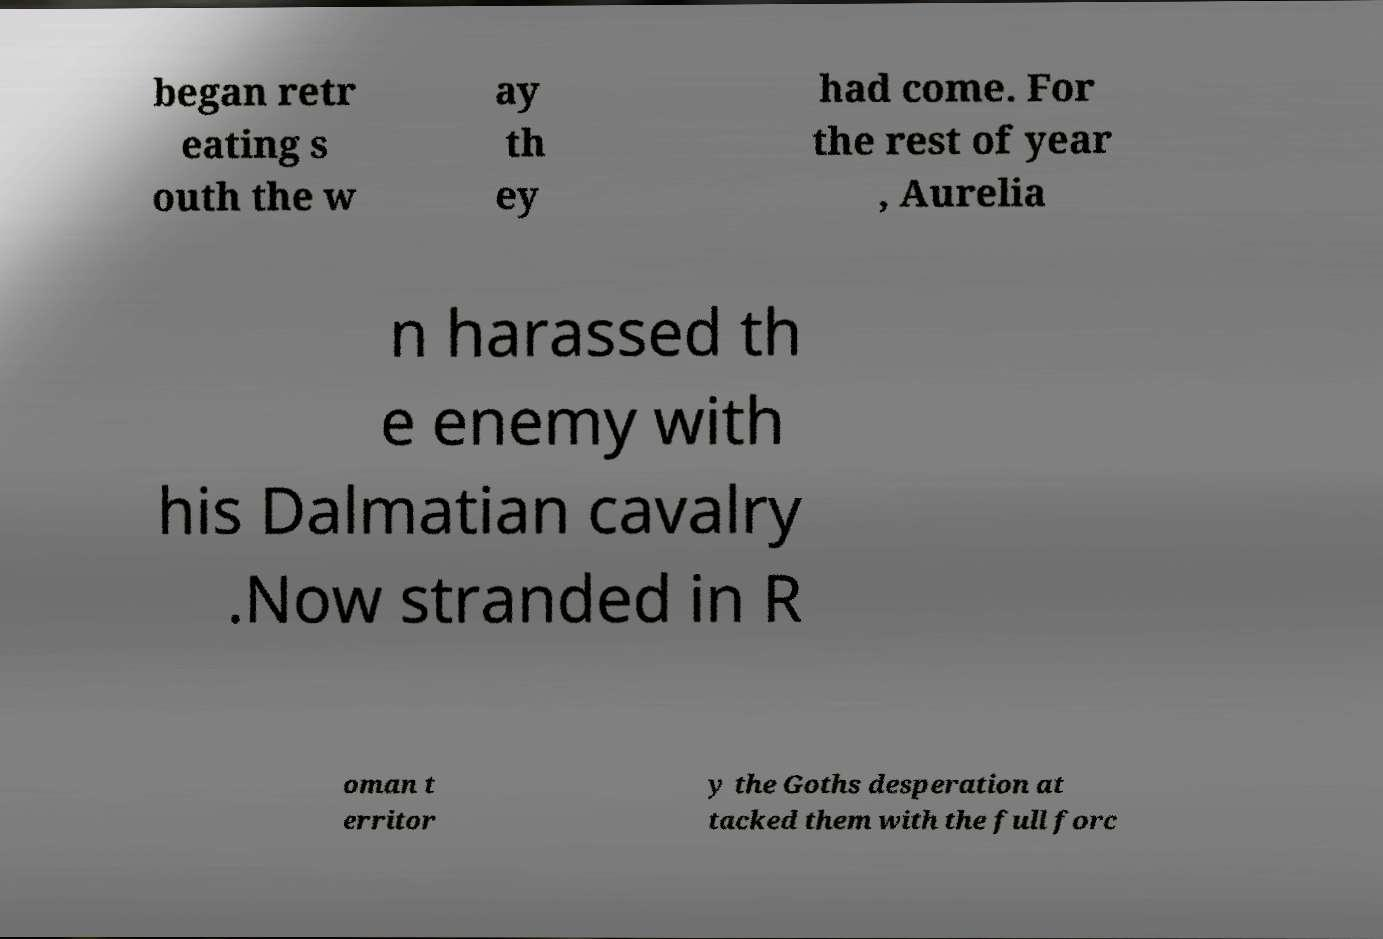I need the written content from this picture converted into text. Can you do that? began retr eating s outh the w ay th ey had come. For the rest of year , Aurelia n harassed th e enemy with his Dalmatian cavalry .Now stranded in R oman t erritor y the Goths desperation at tacked them with the full forc 